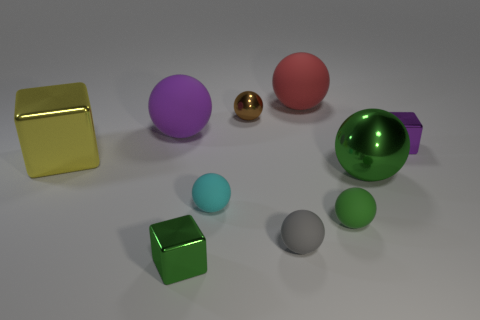What number of cubes have the same color as the large metal sphere?
Provide a succinct answer. 1. How many small objects are brown metallic spheres or brown shiny cubes?
Ensure brevity in your answer.  1. Is there a cyan matte object of the same shape as the large yellow thing?
Offer a very short reply. No. Is the cyan thing the same shape as the purple metallic object?
Offer a very short reply. No. What is the color of the large rubber ball right of the tiny block on the left side of the small shiny ball?
Offer a very short reply. Red. What color is the metallic sphere that is the same size as the red object?
Give a very brief answer. Green. What number of metal objects are either tiny green blocks or small brown balls?
Provide a short and direct response. 2. There is a small metal object that is in front of the small gray ball; what number of tiny green metal objects are on the left side of it?
Your answer should be compact. 0. There is a metal object that is the same color as the big metal sphere; what is its size?
Offer a very short reply. Small. What number of objects are tiny purple metallic blocks or spheres behind the yellow metal thing?
Keep it short and to the point. 4. 